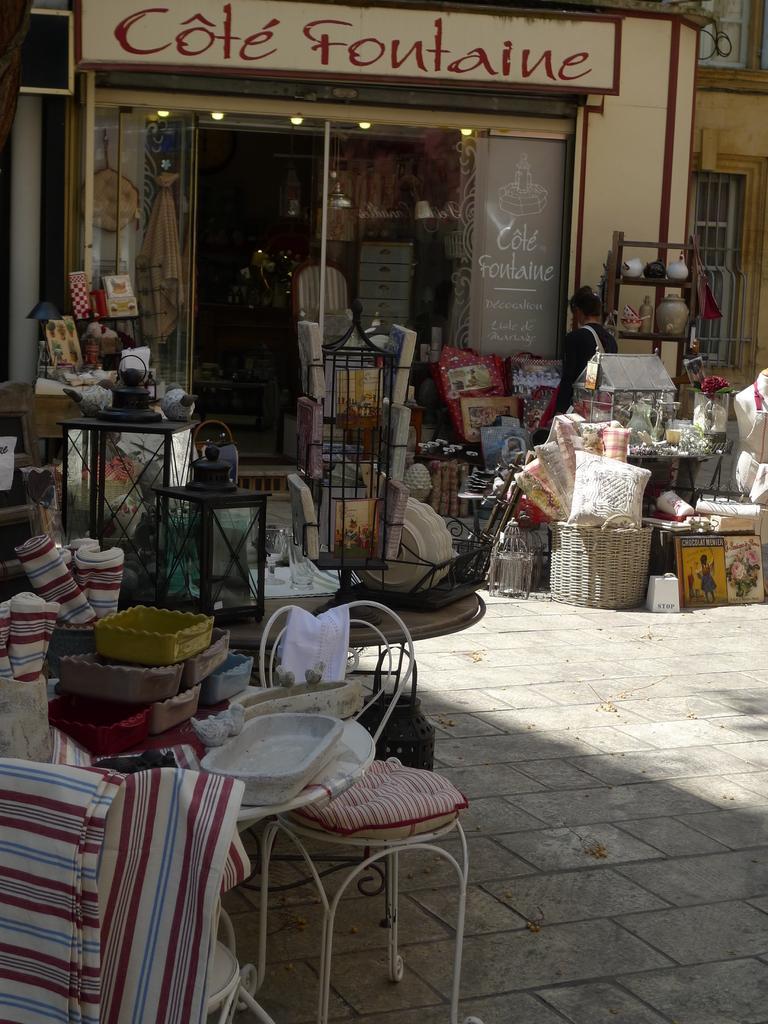In one or two sentences, can you explain what this image depicts? There is a furniture store in this given picture, where there are some pillows, baskets, chairs and some other furniture were there. In the background there is a window. 